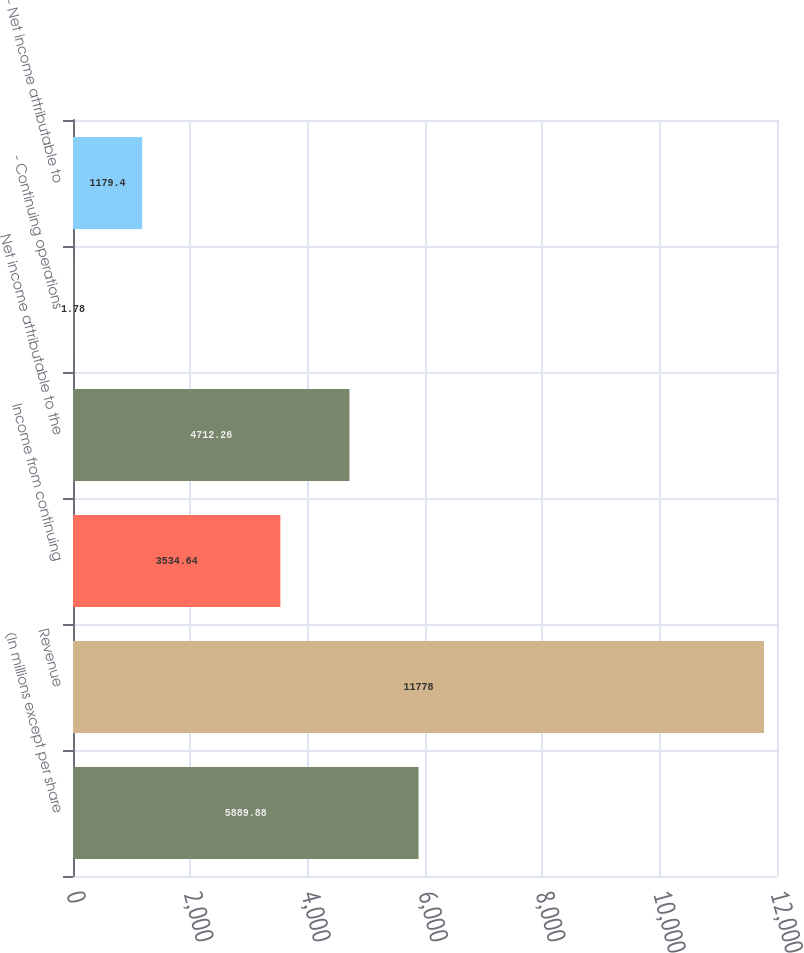Convert chart to OTSL. <chart><loc_0><loc_0><loc_500><loc_500><bar_chart><fcel>(In millions except per share<fcel>Revenue<fcel>Income from continuing<fcel>Net income attributable to the<fcel>- Continuing operations<fcel>- Net income attributable to<nl><fcel>5889.88<fcel>11778<fcel>3534.64<fcel>4712.26<fcel>1.78<fcel>1179.4<nl></chart> 